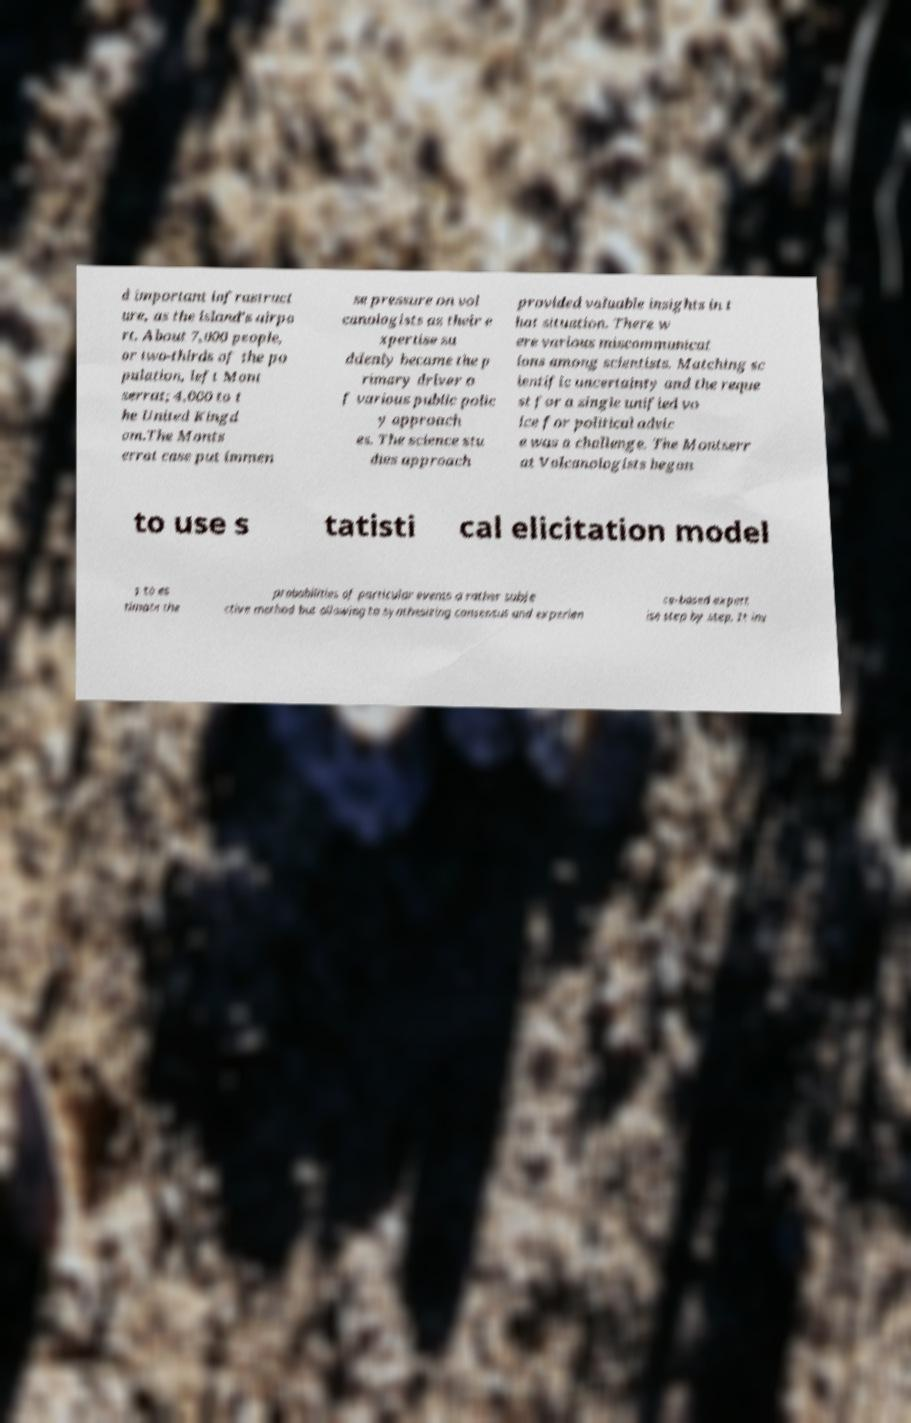There's text embedded in this image that I need extracted. Can you transcribe it verbatim? d important infrastruct ure, as the island's airpo rt. About 7,000 people, or two-thirds of the po pulation, left Mont serrat; 4,000 to t he United Kingd om.The Monts errat case put immen se pressure on vol canologists as their e xpertise su ddenly became the p rimary driver o f various public polic y approach es. The science stu dies approach provided valuable insights in t hat situation. There w ere various miscommunicat ions among scientists. Matching sc ientific uncertainty and the reque st for a single unified vo ice for political advic e was a challenge. The Montserr at Volcanologists began to use s tatisti cal elicitation model s to es timate the probabilities of particular events a rather subje ctive method but allowing to synthesizing consensus and experien ce-based expert ise step by step. It inv 